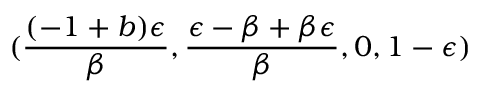Convert formula to latex. <formula><loc_0><loc_0><loc_500><loc_500>( \frac { ( - 1 + b ) \epsilon } { \beta } , \frac { \epsilon - \beta + \beta \epsilon } { \beta } , 0 , 1 - \epsilon )</formula> 